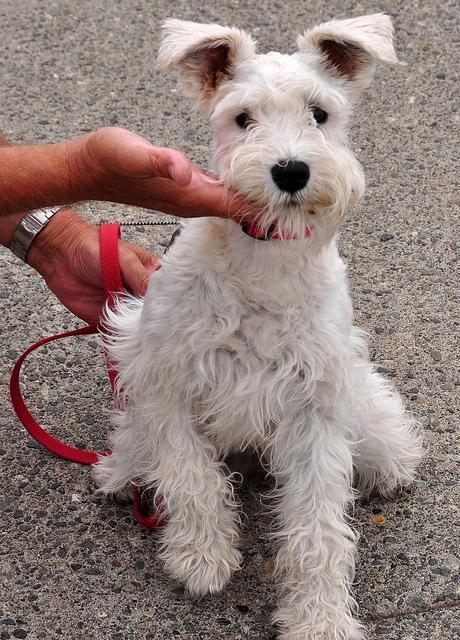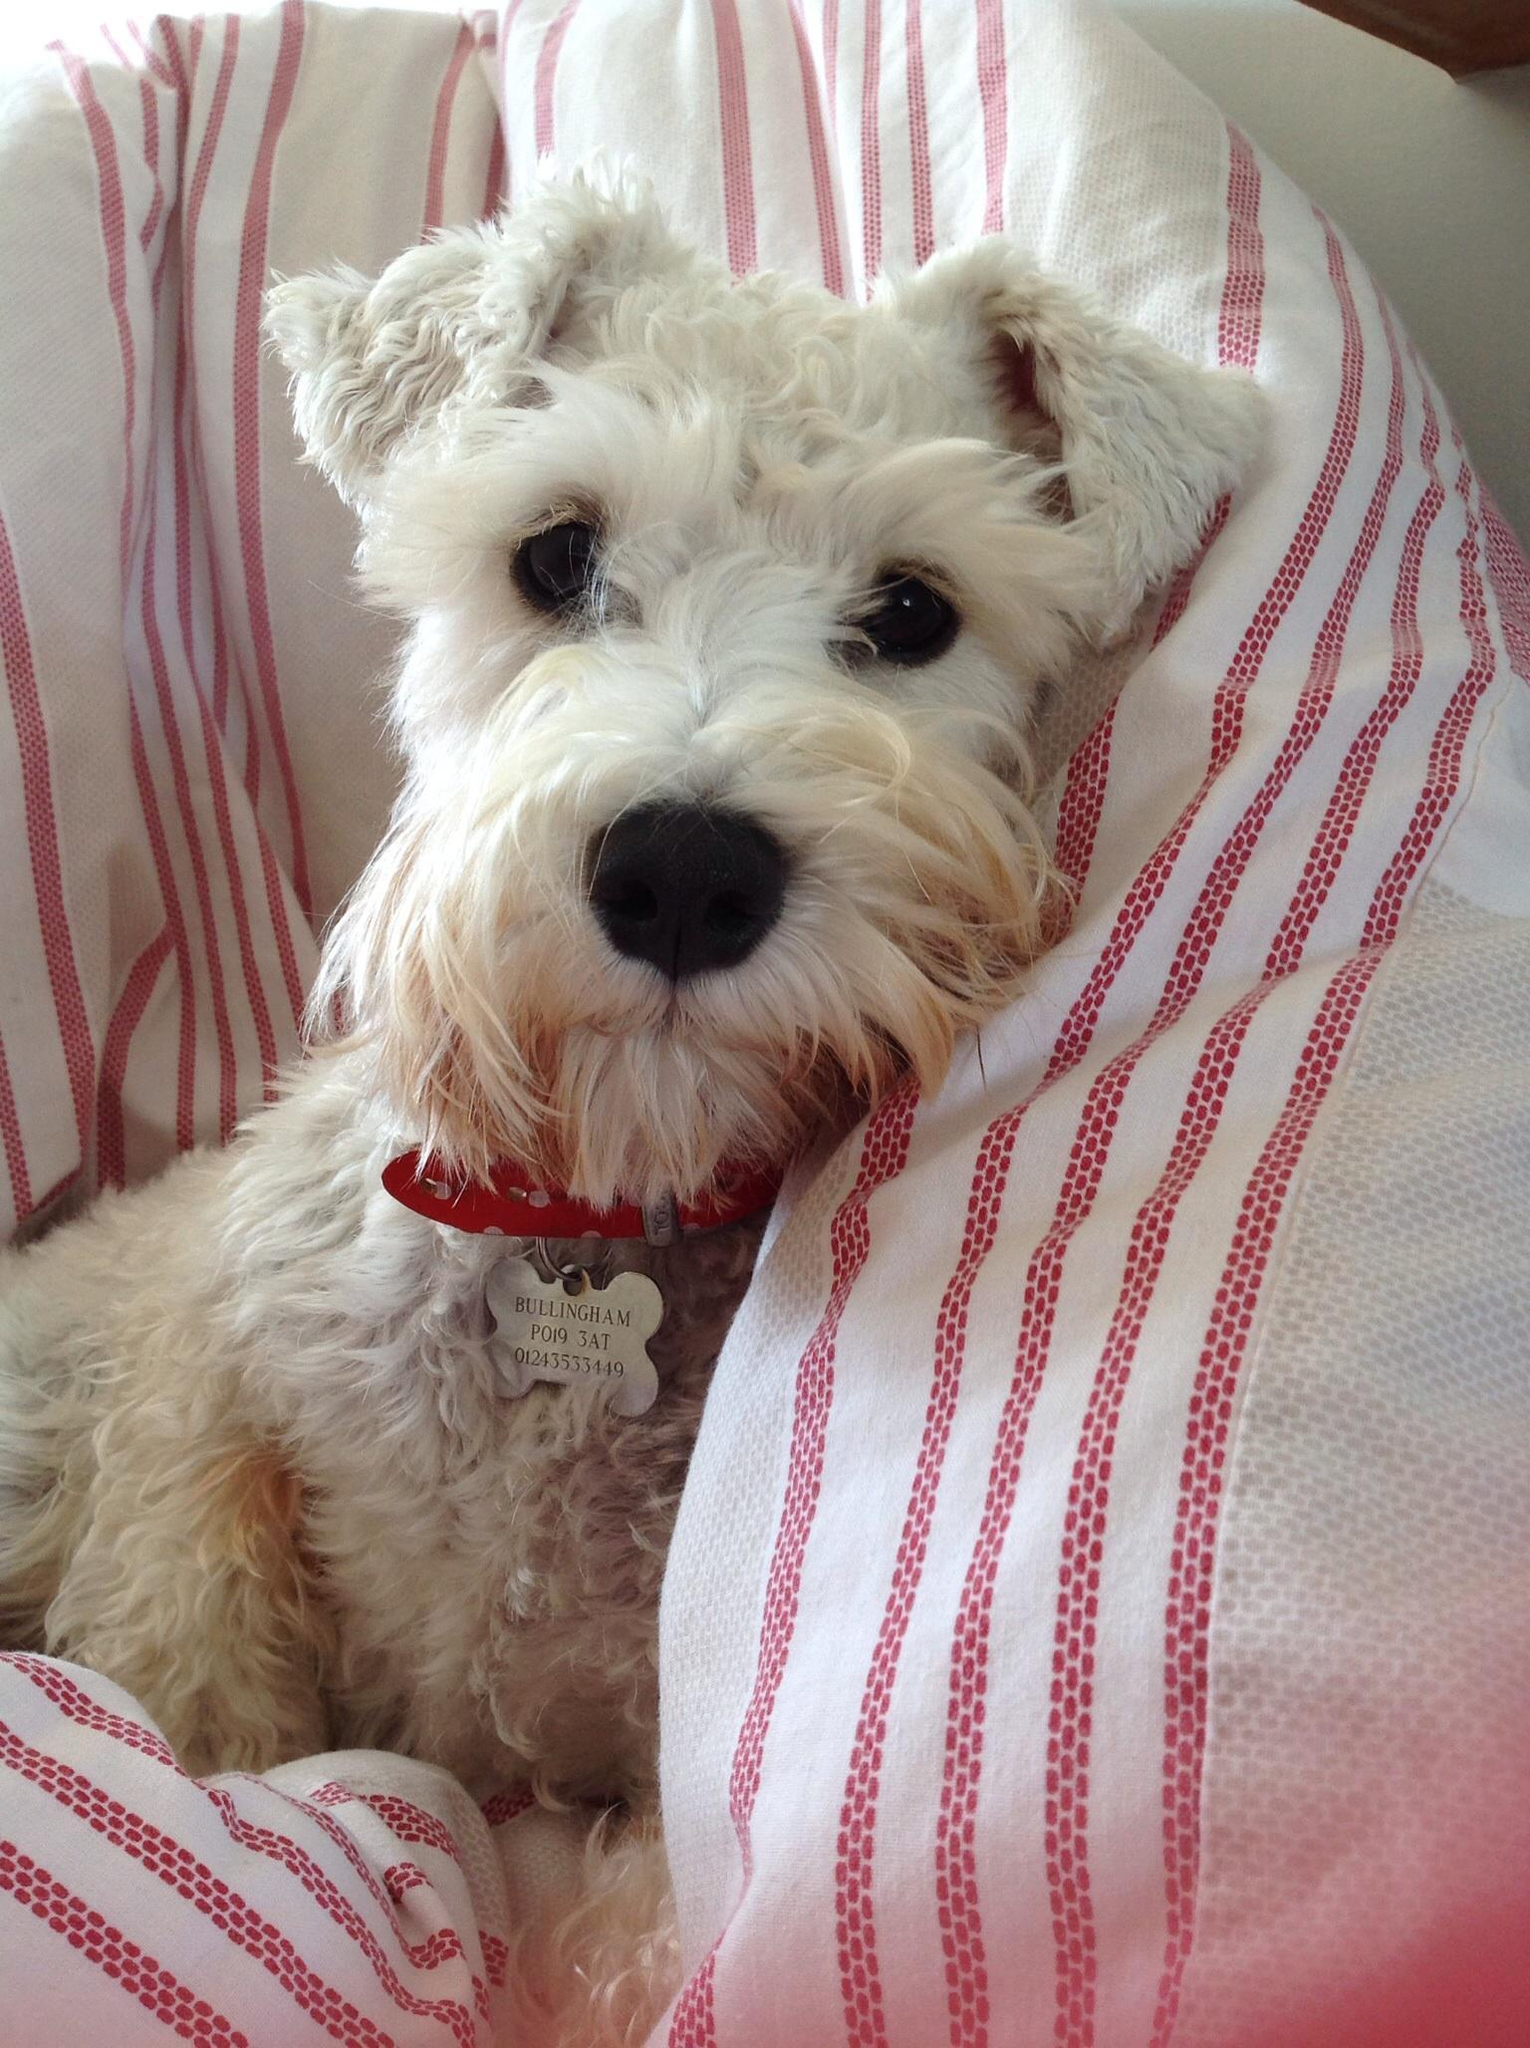The first image is the image on the left, the second image is the image on the right. For the images shown, is this caption "The image on the left is either of a group of puppies huddled together or of a single white dog wearing a red collar." true? Answer yes or no. Yes. The first image is the image on the left, the second image is the image on the right. Assess this claim about the two images: "Each image contains one white dog, and the dog on the right is posed by striped fabric.". Correct or not? Answer yes or no. Yes. 